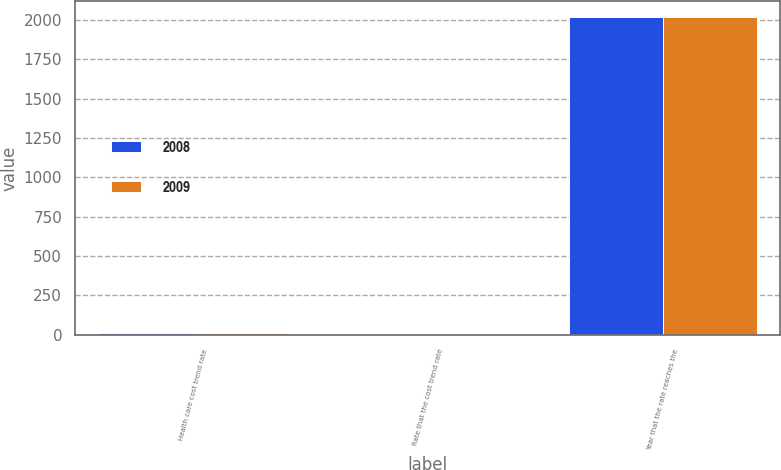Convert chart to OTSL. <chart><loc_0><loc_0><loc_500><loc_500><stacked_bar_chart><ecel><fcel>Health care cost trend rate<fcel>Rate that the cost trend rate<fcel>Year that the rate reaches the<nl><fcel>2008<fcel>9<fcel>5<fcel>2017<nl><fcel>2009<fcel>9.5<fcel>5<fcel>2017<nl></chart> 